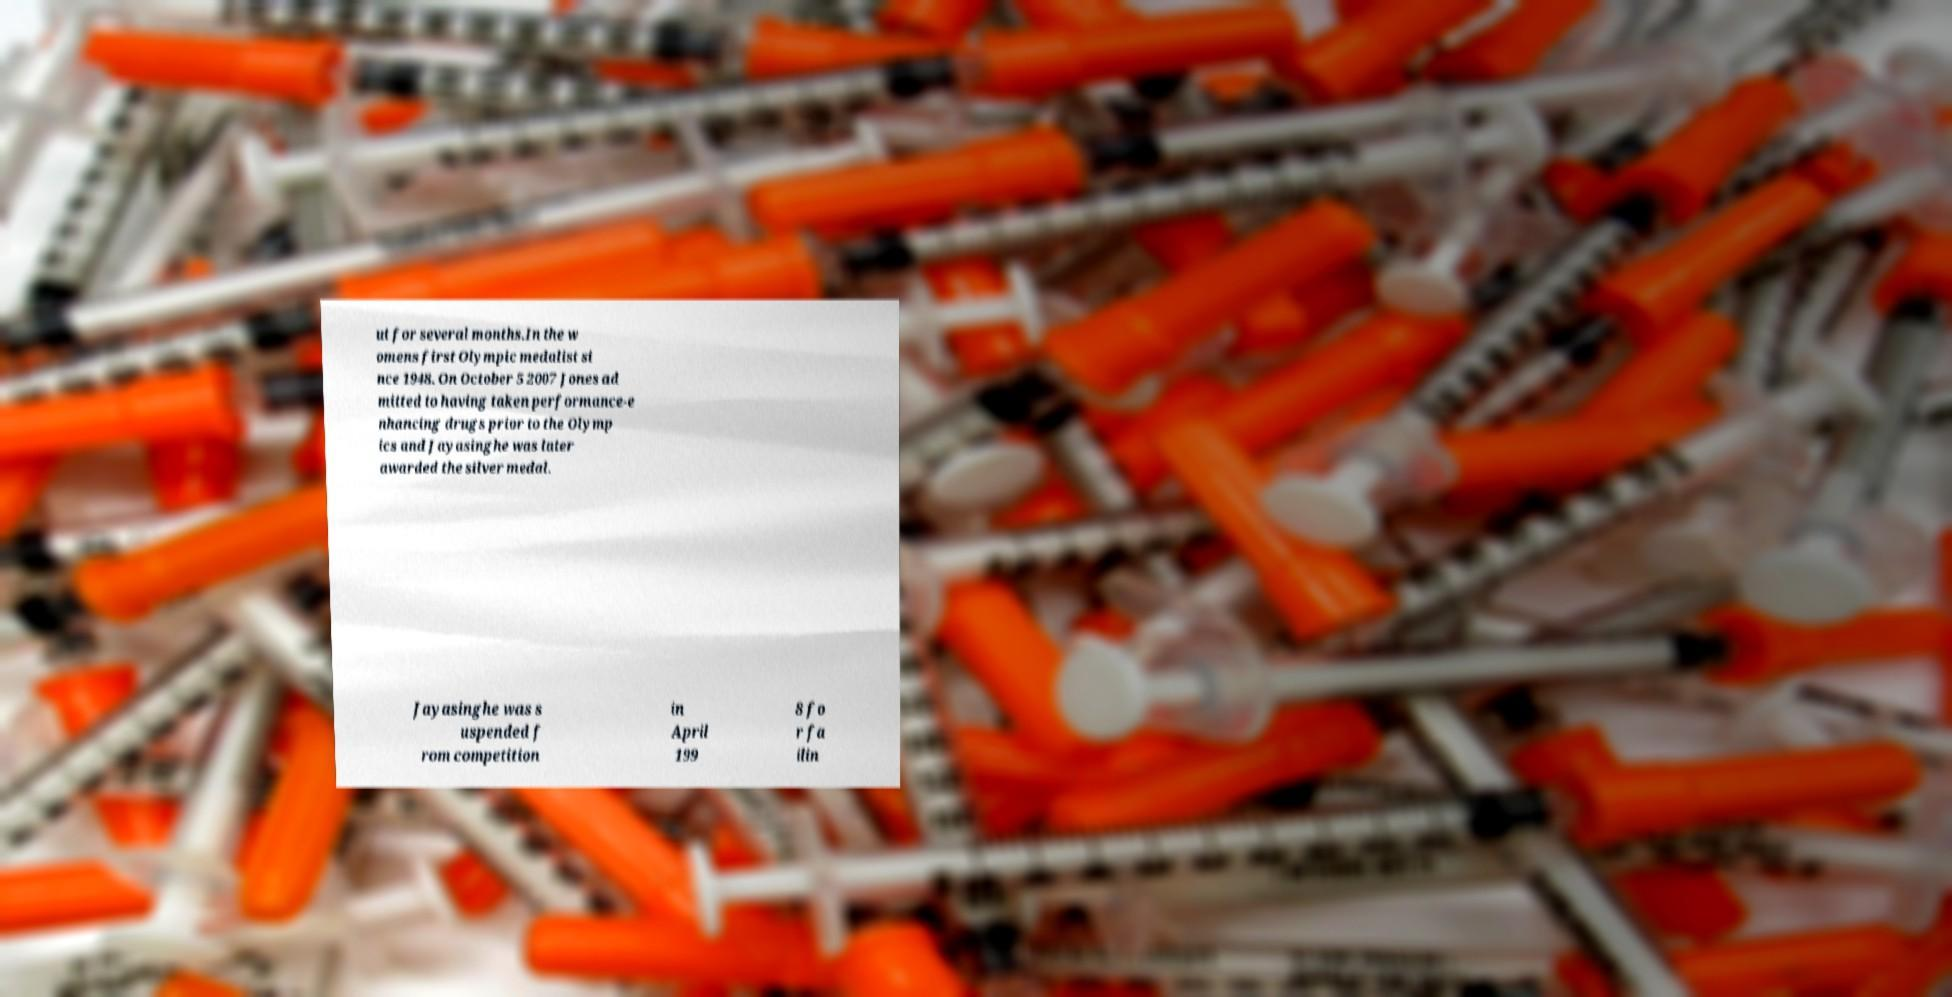For documentation purposes, I need the text within this image transcribed. Could you provide that? ut for several months.In the w omens first Olympic medalist si nce 1948. On October 5 2007 Jones ad mitted to having taken performance-e nhancing drugs prior to the Olymp ics and Jayasinghe was later awarded the silver medal. Jayasinghe was s uspended f rom competition in April 199 8 fo r fa ilin 